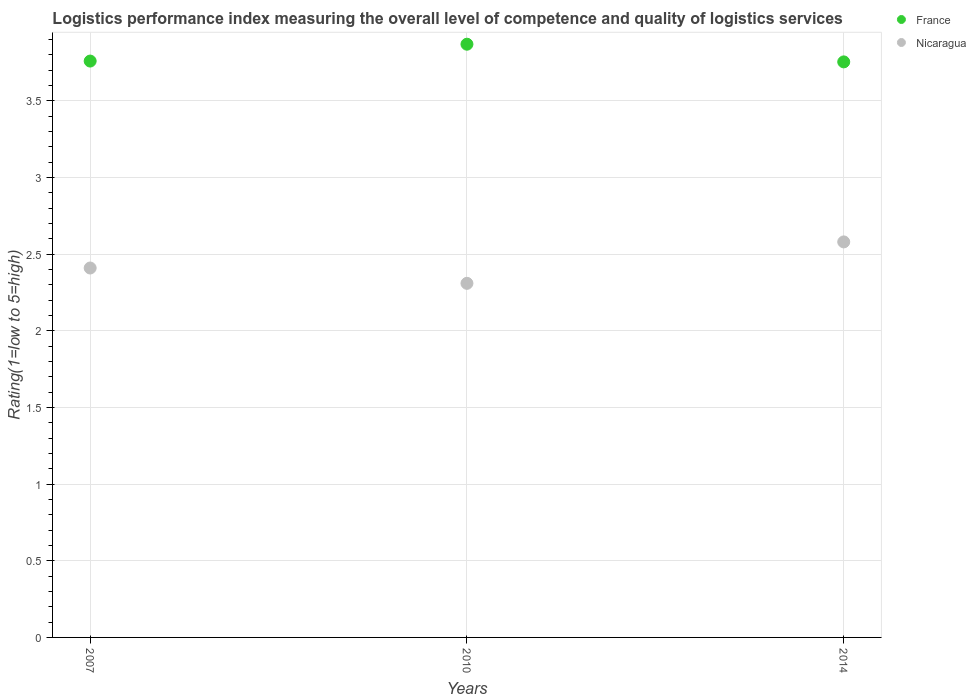How many different coloured dotlines are there?
Ensure brevity in your answer.  2. What is the Logistic performance index in France in 2007?
Offer a very short reply. 3.76. Across all years, what is the maximum Logistic performance index in France?
Offer a terse response. 3.87. Across all years, what is the minimum Logistic performance index in France?
Give a very brief answer. 3.75. What is the total Logistic performance index in France in the graph?
Provide a succinct answer. 11.38. What is the difference between the Logistic performance index in France in 2010 and that in 2014?
Provide a short and direct response. 0.12. What is the difference between the Logistic performance index in France in 2014 and the Logistic performance index in Nicaragua in 2010?
Keep it short and to the point. 1.44. What is the average Logistic performance index in France per year?
Your response must be concise. 3.79. In the year 2007, what is the difference between the Logistic performance index in France and Logistic performance index in Nicaragua?
Ensure brevity in your answer.  1.35. What is the ratio of the Logistic performance index in Nicaragua in 2007 to that in 2010?
Your response must be concise. 1.04. Is the difference between the Logistic performance index in France in 2010 and 2014 greater than the difference between the Logistic performance index in Nicaragua in 2010 and 2014?
Your answer should be compact. Yes. What is the difference between the highest and the second highest Logistic performance index in France?
Your response must be concise. 0.11. What is the difference between the highest and the lowest Logistic performance index in Nicaragua?
Offer a very short reply. 0.27. In how many years, is the Logistic performance index in France greater than the average Logistic performance index in France taken over all years?
Make the answer very short. 1. Is the sum of the Logistic performance index in Nicaragua in 2007 and 2010 greater than the maximum Logistic performance index in France across all years?
Your answer should be compact. Yes. Is the Logistic performance index in Nicaragua strictly greater than the Logistic performance index in France over the years?
Offer a very short reply. No. Does the graph contain any zero values?
Your response must be concise. No. How are the legend labels stacked?
Your answer should be compact. Vertical. What is the title of the graph?
Ensure brevity in your answer.  Logistics performance index measuring the overall level of competence and quality of logistics services. Does "Dominican Republic" appear as one of the legend labels in the graph?
Make the answer very short. No. What is the label or title of the Y-axis?
Give a very brief answer. Rating(1=low to 5=high). What is the Rating(1=low to 5=high) in France in 2007?
Your answer should be compact. 3.76. What is the Rating(1=low to 5=high) in Nicaragua in 2007?
Provide a succinct answer. 2.41. What is the Rating(1=low to 5=high) in France in 2010?
Your answer should be very brief. 3.87. What is the Rating(1=low to 5=high) of Nicaragua in 2010?
Offer a very short reply. 2.31. What is the Rating(1=low to 5=high) in France in 2014?
Provide a short and direct response. 3.75. What is the Rating(1=low to 5=high) of Nicaragua in 2014?
Provide a short and direct response. 2.58. Across all years, what is the maximum Rating(1=low to 5=high) of France?
Your answer should be compact. 3.87. Across all years, what is the maximum Rating(1=low to 5=high) of Nicaragua?
Make the answer very short. 2.58. Across all years, what is the minimum Rating(1=low to 5=high) in France?
Keep it short and to the point. 3.75. Across all years, what is the minimum Rating(1=low to 5=high) of Nicaragua?
Provide a succinct answer. 2.31. What is the total Rating(1=low to 5=high) in France in the graph?
Your answer should be very brief. 11.38. What is the total Rating(1=low to 5=high) of Nicaragua in the graph?
Make the answer very short. 7.3. What is the difference between the Rating(1=low to 5=high) of France in 2007 and that in 2010?
Your answer should be very brief. -0.11. What is the difference between the Rating(1=low to 5=high) in France in 2007 and that in 2014?
Your answer should be very brief. 0.01. What is the difference between the Rating(1=low to 5=high) in Nicaragua in 2007 and that in 2014?
Your response must be concise. -0.17. What is the difference between the Rating(1=low to 5=high) of France in 2010 and that in 2014?
Your answer should be very brief. 0.12. What is the difference between the Rating(1=low to 5=high) in Nicaragua in 2010 and that in 2014?
Provide a succinct answer. -0.27. What is the difference between the Rating(1=low to 5=high) in France in 2007 and the Rating(1=low to 5=high) in Nicaragua in 2010?
Your response must be concise. 1.45. What is the difference between the Rating(1=low to 5=high) in France in 2007 and the Rating(1=low to 5=high) in Nicaragua in 2014?
Provide a short and direct response. 1.18. What is the difference between the Rating(1=low to 5=high) in France in 2010 and the Rating(1=low to 5=high) in Nicaragua in 2014?
Offer a very short reply. 1.29. What is the average Rating(1=low to 5=high) in France per year?
Keep it short and to the point. 3.79. What is the average Rating(1=low to 5=high) in Nicaragua per year?
Keep it short and to the point. 2.43. In the year 2007, what is the difference between the Rating(1=low to 5=high) of France and Rating(1=low to 5=high) of Nicaragua?
Keep it short and to the point. 1.35. In the year 2010, what is the difference between the Rating(1=low to 5=high) in France and Rating(1=low to 5=high) in Nicaragua?
Your answer should be very brief. 1.56. In the year 2014, what is the difference between the Rating(1=low to 5=high) of France and Rating(1=low to 5=high) of Nicaragua?
Keep it short and to the point. 1.17. What is the ratio of the Rating(1=low to 5=high) of France in 2007 to that in 2010?
Provide a succinct answer. 0.97. What is the ratio of the Rating(1=low to 5=high) in Nicaragua in 2007 to that in 2010?
Keep it short and to the point. 1.04. What is the ratio of the Rating(1=low to 5=high) in Nicaragua in 2007 to that in 2014?
Ensure brevity in your answer.  0.93. What is the ratio of the Rating(1=low to 5=high) of France in 2010 to that in 2014?
Offer a terse response. 1.03. What is the ratio of the Rating(1=low to 5=high) of Nicaragua in 2010 to that in 2014?
Ensure brevity in your answer.  0.9. What is the difference between the highest and the second highest Rating(1=low to 5=high) of France?
Offer a terse response. 0.11. What is the difference between the highest and the second highest Rating(1=low to 5=high) in Nicaragua?
Your answer should be compact. 0.17. What is the difference between the highest and the lowest Rating(1=low to 5=high) in France?
Offer a very short reply. 0.12. What is the difference between the highest and the lowest Rating(1=low to 5=high) in Nicaragua?
Your answer should be compact. 0.27. 